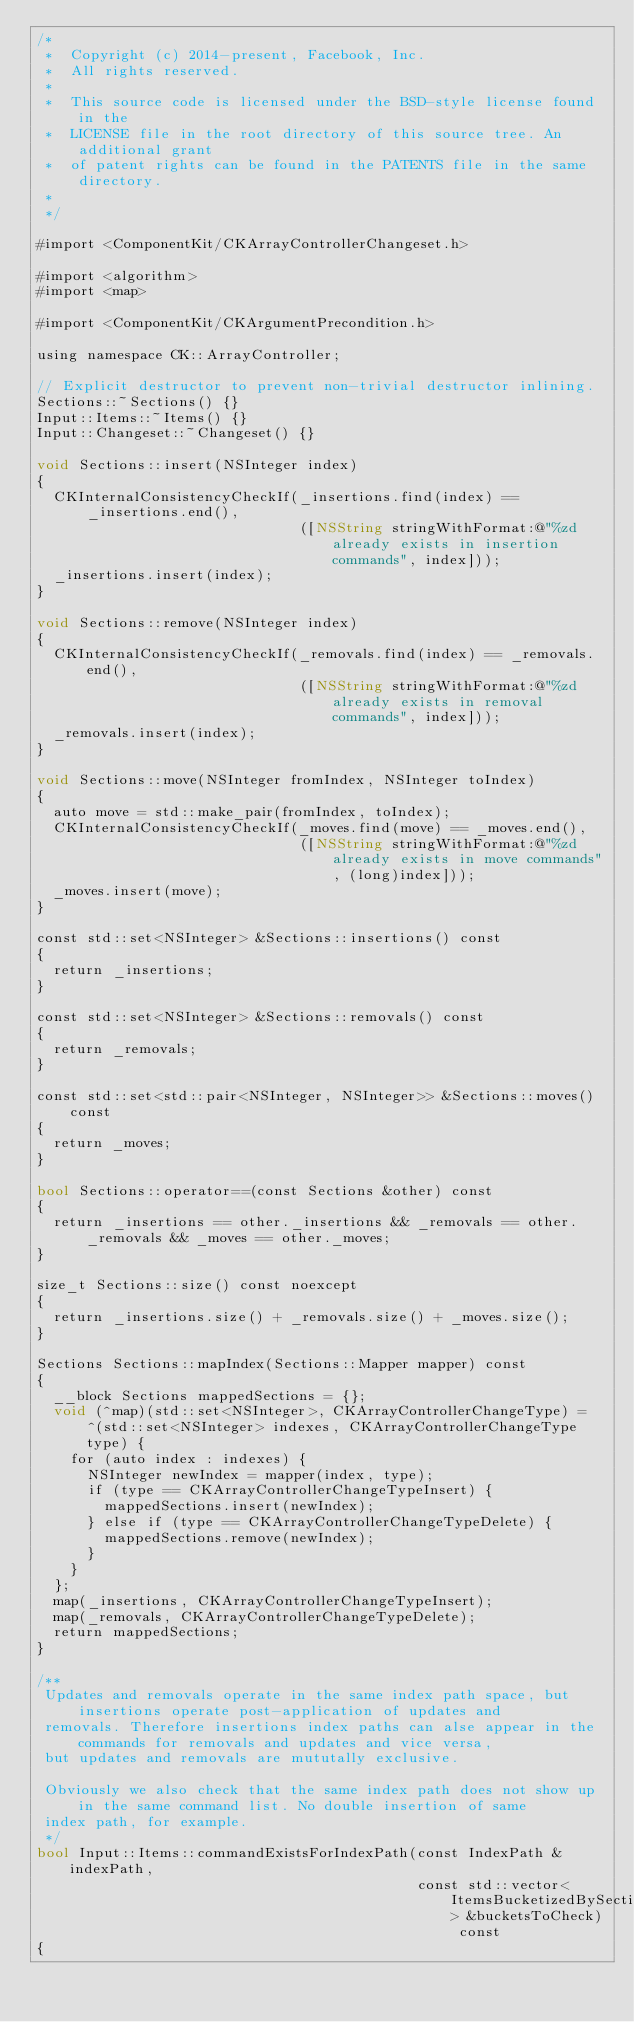<code> <loc_0><loc_0><loc_500><loc_500><_ObjectiveC_>/*
 *  Copyright (c) 2014-present, Facebook, Inc.
 *  All rights reserved.
 *
 *  This source code is licensed under the BSD-style license found in the
 *  LICENSE file in the root directory of this source tree. An additional grant
 *  of patent rights can be found in the PATENTS file in the same directory.
 *
 */

#import <ComponentKit/CKArrayControllerChangeset.h>

#import <algorithm>
#import <map>

#import <ComponentKit/CKArgumentPrecondition.h>

using namespace CK::ArrayController;

// Explicit destructor to prevent non-trivial destructor inlining.
Sections::~Sections() {}
Input::Items::~Items() {}
Input::Changeset::~Changeset() {}

void Sections::insert(NSInteger index)
{
  CKInternalConsistencyCheckIf(_insertions.find(index) == _insertions.end(),
                               ([NSString stringWithFormat:@"%zd already exists in insertion commands", index]));
  _insertions.insert(index);
}

void Sections::remove(NSInteger index)
{
  CKInternalConsistencyCheckIf(_removals.find(index) == _removals.end(),
                               ([NSString stringWithFormat:@"%zd already exists in removal commands", index]));
  _removals.insert(index);
}

void Sections::move(NSInteger fromIndex, NSInteger toIndex)
{
  auto move = std::make_pair(fromIndex, toIndex);
  CKInternalConsistencyCheckIf(_moves.find(move) == _moves.end(),
                               ([NSString stringWithFormat:@"%zd already exists in move commands", (long)index]));
  _moves.insert(move);
}

const std::set<NSInteger> &Sections::insertions() const
{
  return _insertions;
}

const std::set<NSInteger> &Sections::removals() const
{
  return _removals;
}

const std::set<std::pair<NSInteger, NSInteger>> &Sections::moves() const
{
  return _moves;
}

bool Sections::operator==(const Sections &other) const
{
  return _insertions == other._insertions && _removals == other._removals && _moves == other._moves;
}

size_t Sections::size() const noexcept
{
  return _insertions.size() + _removals.size() + _moves.size();
}

Sections Sections::mapIndex(Sections::Mapper mapper) const
{
  __block Sections mappedSections = {};
  void (^map)(std::set<NSInteger>, CKArrayControllerChangeType) = ^(std::set<NSInteger> indexes, CKArrayControllerChangeType type) {
    for (auto index : indexes) {
      NSInteger newIndex = mapper(index, type);
      if (type == CKArrayControllerChangeTypeInsert) {
        mappedSections.insert(newIndex);
      } else if (type == CKArrayControllerChangeTypeDelete) {
        mappedSections.remove(newIndex);
      }
    }
  };
  map(_insertions, CKArrayControllerChangeTypeInsert);
  map(_removals, CKArrayControllerChangeTypeDelete);
  return mappedSections;
}

/**
 Updates and removals operate in the same index path space, but insertions operate post-application of updates and
 removals. Therefore insertions index paths can alse appear in the commands for removals and updates and vice versa,
 but updates and removals are mututally exclusive.

 Obviously we also check that the same index path does not show up in the same command list. No double insertion of same
 index path, for example.
 */
bool Input::Items::commandExistsForIndexPath(const IndexPath &indexPath,
                                             const std::vector<ItemsBucketizedBySection> &bucketsToCheck) const
{</code> 